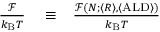Convert formula to latex. <formula><loc_0><loc_0><loc_500><loc_500>\begin{array} { r l r } { \frac { \mathcal { F } } { k _ { B } T } } & \equiv } & { \frac { \mathcal { F } ( N ; \langle R \rangle , \langle A L D \rangle ) } { k _ { B } T } } \end{array}</formula> 